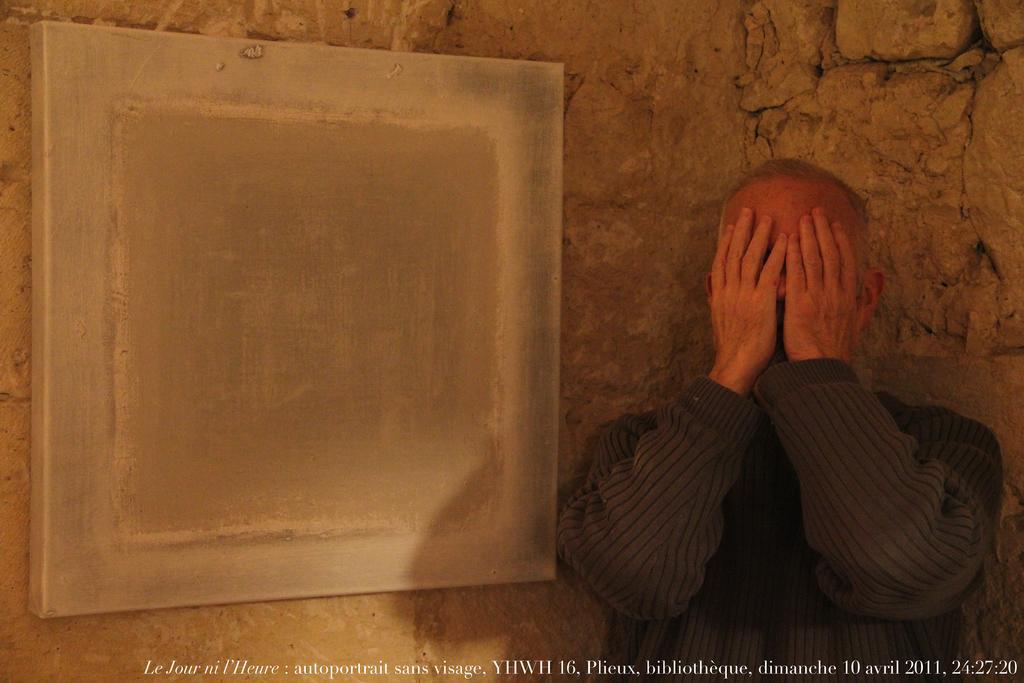Can you describe this image briefly? In this image I can see a person, text, board and a wall of stones. This image is taken may be in a building. 